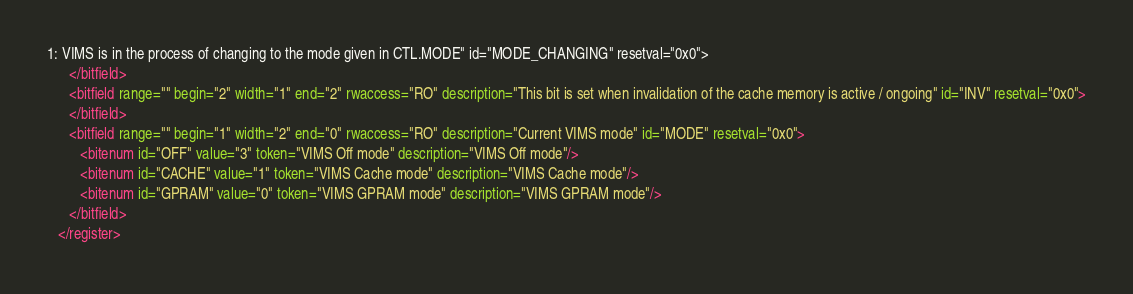Convert code to text. <code><loc_0><loc_0><loc_500><loc_500><_XML_>1: VIMS is in the process of changing to the mode given in CTL.MODE" id="MODE_CHANGING" resetval="0x0">
      </bitfield>
      <bitfield range="" begin="2" width="1" end="2" rwaccess="RO" description="This bit is set when invalidation of the cache memory is active / ongoing" id="INV" resetval="0x0">
      </bitfield>
      <bitfield range="" begin="1" width="2" end="0" rwaccess="RO" description="Current VIMS mode" id="MODE" resetval="0x0">
         <bitenum id="OFF" value="3" token="VIMS Off mode" description="VIMS Off mode"/>
         <bitenum id="CACHE" value="1" token="VIMS Cache mode" description="VIMS Cache mode"/>
         <bitenum id="GPRAM" value="0" token="VIMS GPRAM mode" description="VIMS GPRAM mode"/>
      </bitfield>
   </register></code> 